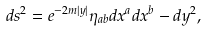<formula> <loc_0><loc_0><loc_500><loc_500>d s ^ { 2 } = e ^ { - 2 m | y | } \eta _ { a b } d x ^ { a } d x ^ { b } - d y ^ { 2 } ,</formula> 